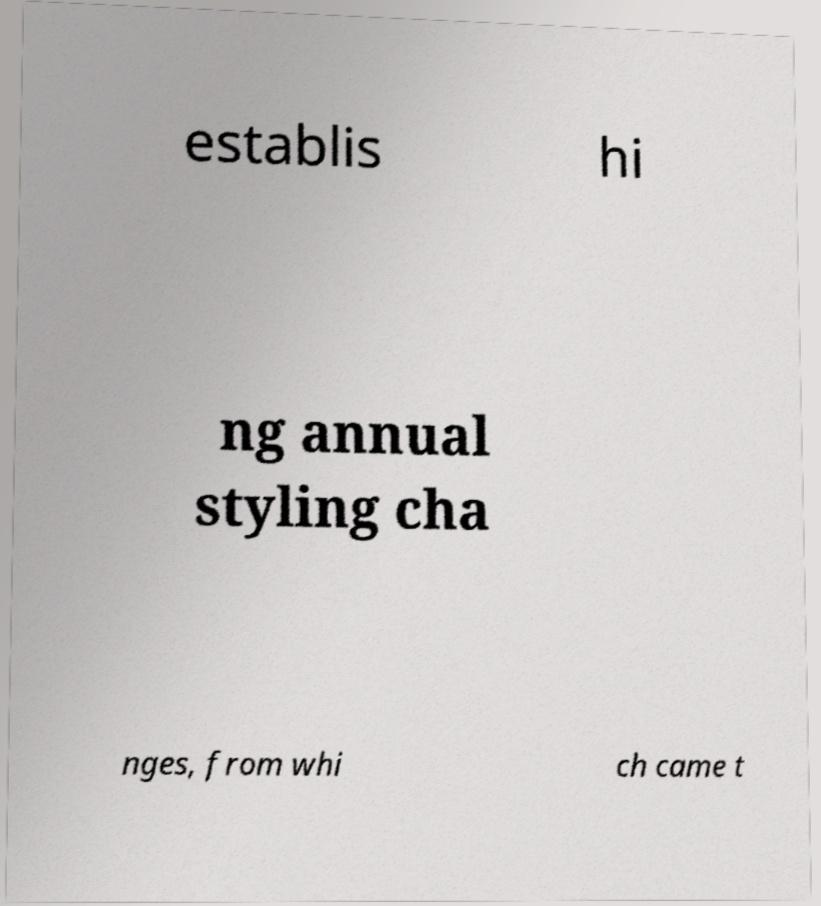Could you assist in decoding the text presented in this image and type it out clearly? establis hi ng annual styling cha nges, from whi ch came t 